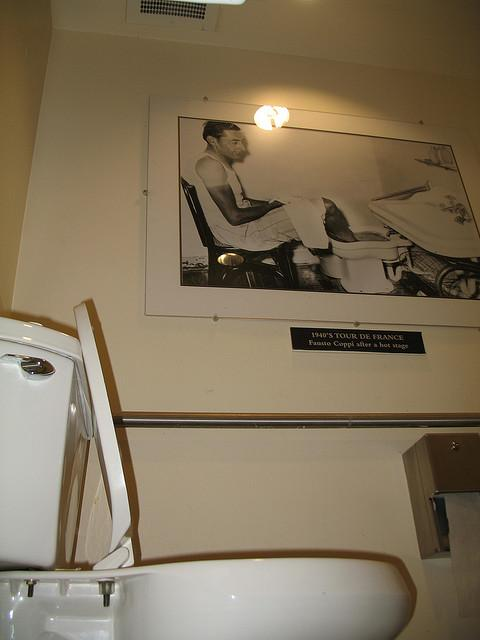What kind of athlete was the man in the black and white image most likely? runner 